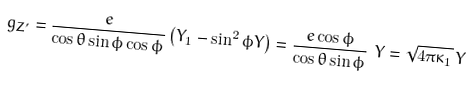<formula> <loc_0><loc_0><loc_500><loc_500>g _ { Z ^ { \prime } } = \frac { e } { \cos { \theta } \sin { \phi } \cos { \phi } } \left ( Y _ { 1 } - \sin ^ { 2 } { \phi } Y \right ) = \frac { e \cos { \phi } } { \cos { \theta } \sin { \phi } } \ Y = \sqrt { 4 \pi \kappa _ { 1 } } \, Y</formula> 